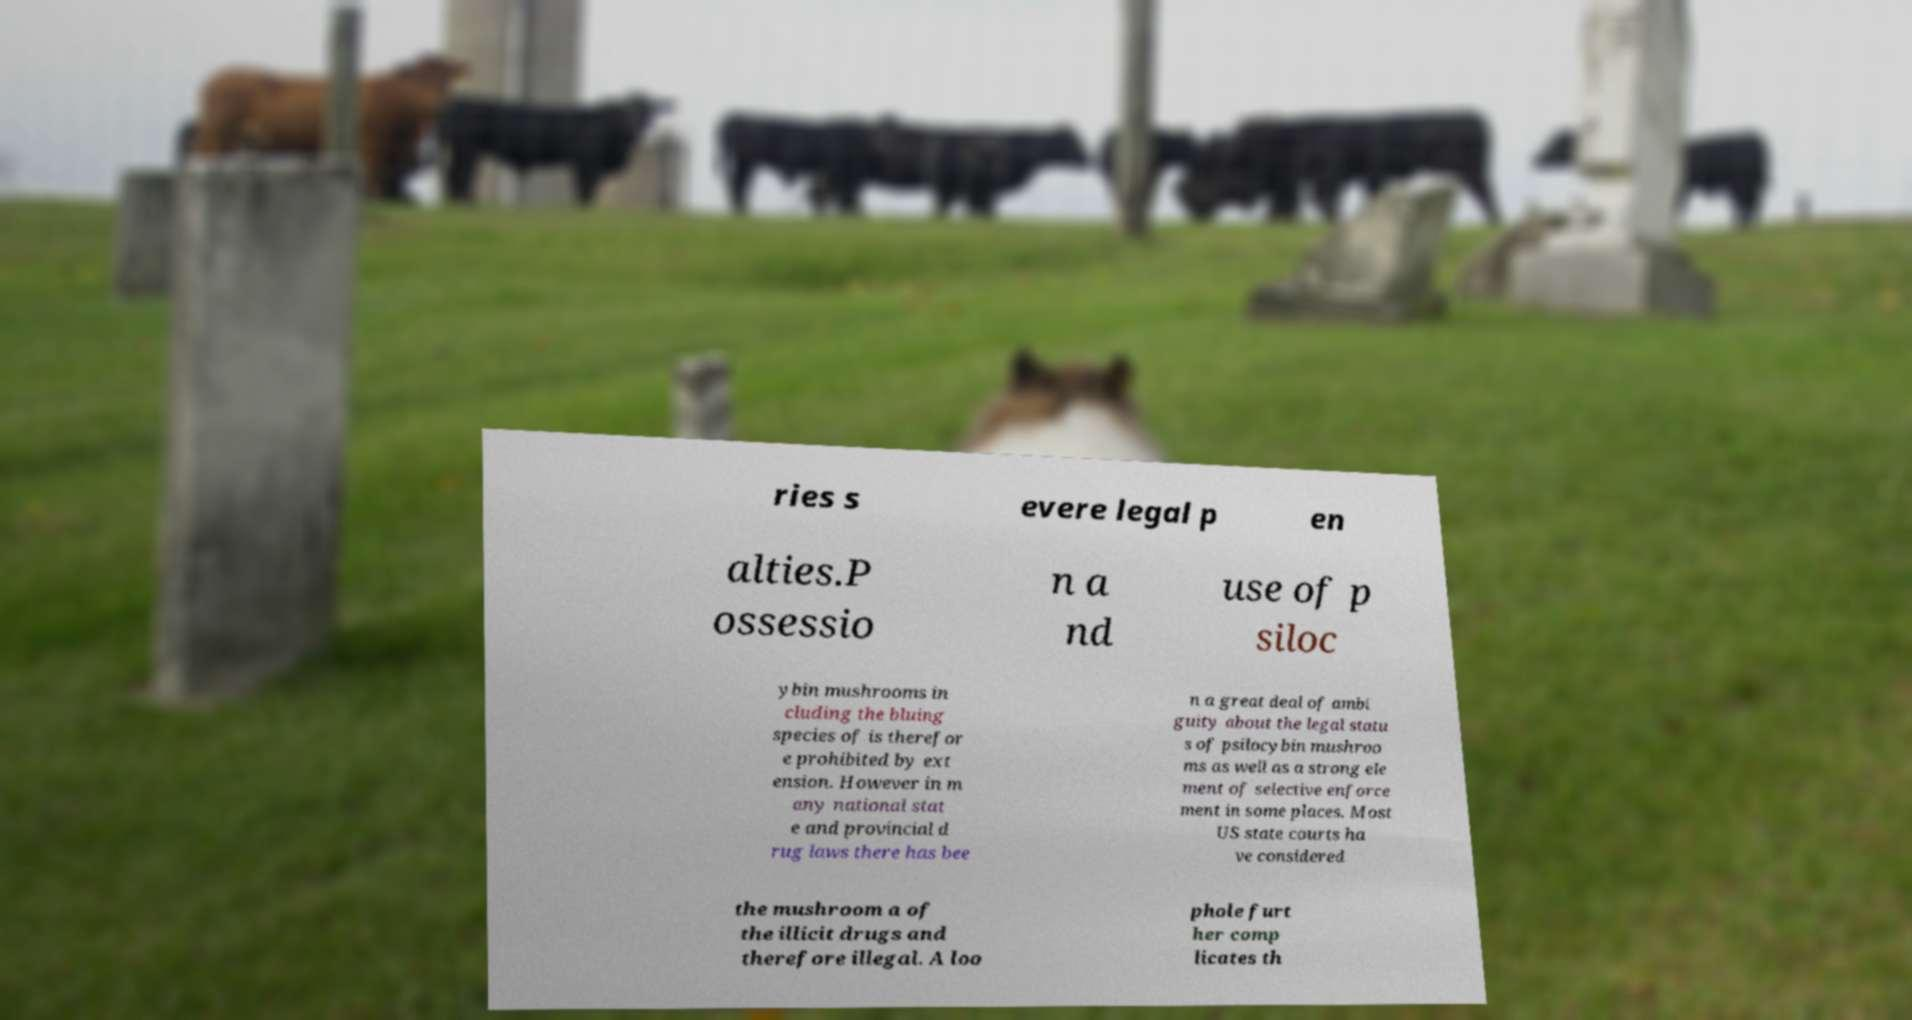There's text embedded in this image that I need extracted. Can you transcribe it verbatim? ries s evere legal p en alties.P ossessio n a nd use of p siloc ybin mushrooms in cluding the bluing species of is therefor e prohibited by ext ension. However in m any national stat e and provincial d rug laws there has bee n a great deal of ambi guity about the legal statu s of psilocybin mushroo ms as well as a strong ele ment of selective enforce ment in some places. Most US state courts ha ve considered the mushroom a of the illicit drugs and therefore illegal. A loo phole furt her comp licates th 